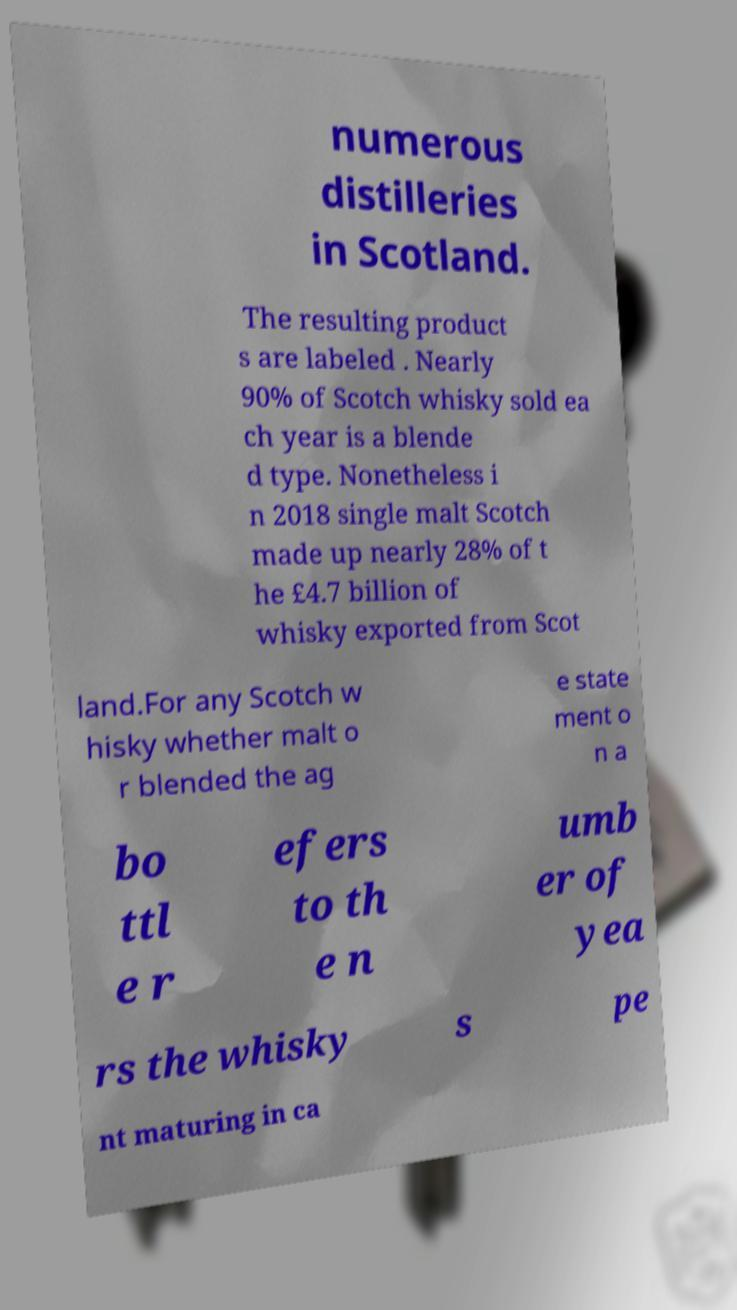Can you read and provide the text displayed in the image?This photo seems to have some interesting text. Can you extract and type it out for me? numerous distilleries in Scotland. The resulting product s are labeled . Nearly 90% of Scotch whisky sold ea ch year is a blende d type. Nonetheless i n 2018 single malt Scotch made up nearly 28% of t he £4.7 billion of whisky exported from Scot land.For any Scotch w hisky whether malt o r blended the ag e state ment o n a bo ttl e r efers to th e n umb er of yea rs the whisky s pe nt maturing in ca 